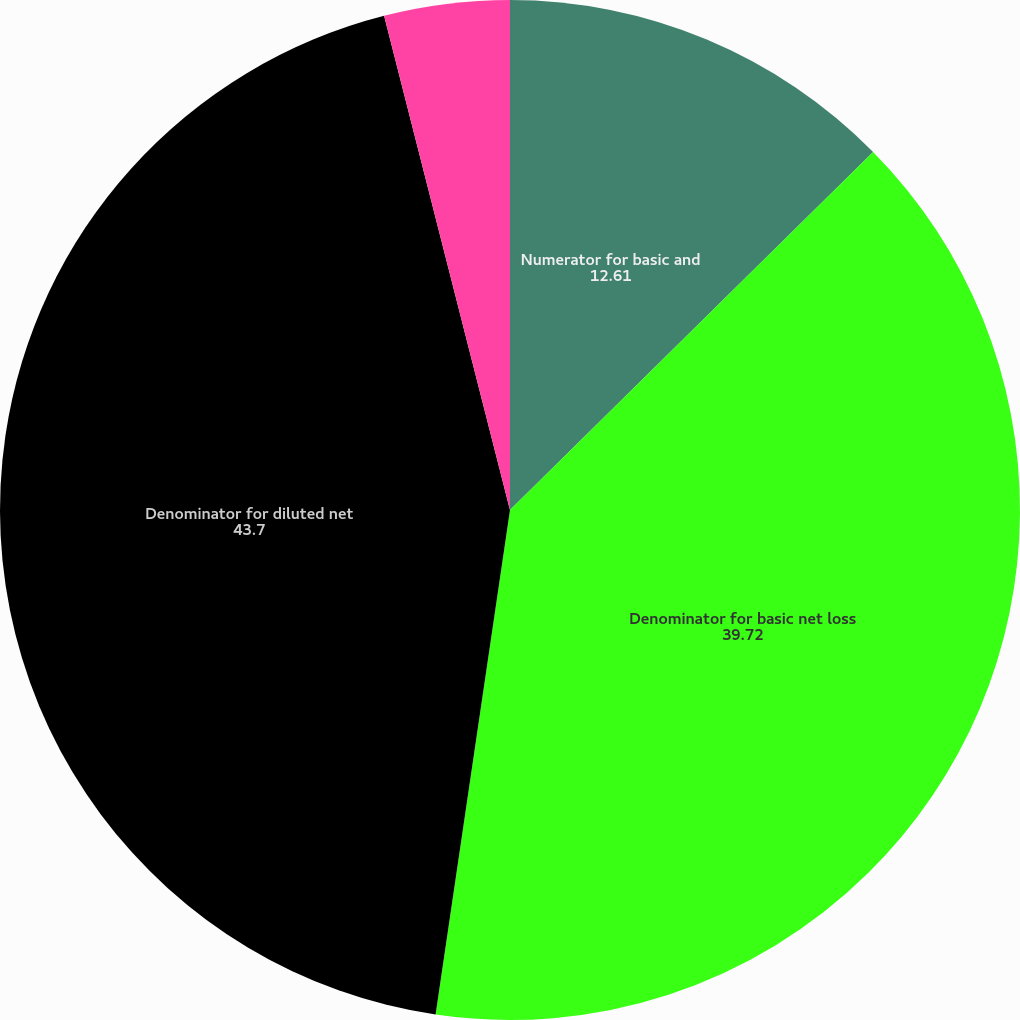<chart> <loc_0><loc_0><loc_500><loc_500><pie_chart><fcel>Numerator for basic and<fcel>Denominator for basic net loss<fcel>Denominator for diluted net<fcel>Basic net loss per share<fcel>Diluted net loss per share<nl><fcel>12.61%<fcel>39.72%<fcel>43.7%<fcel>0.0%<fcel>3.97%<nl></chart> 